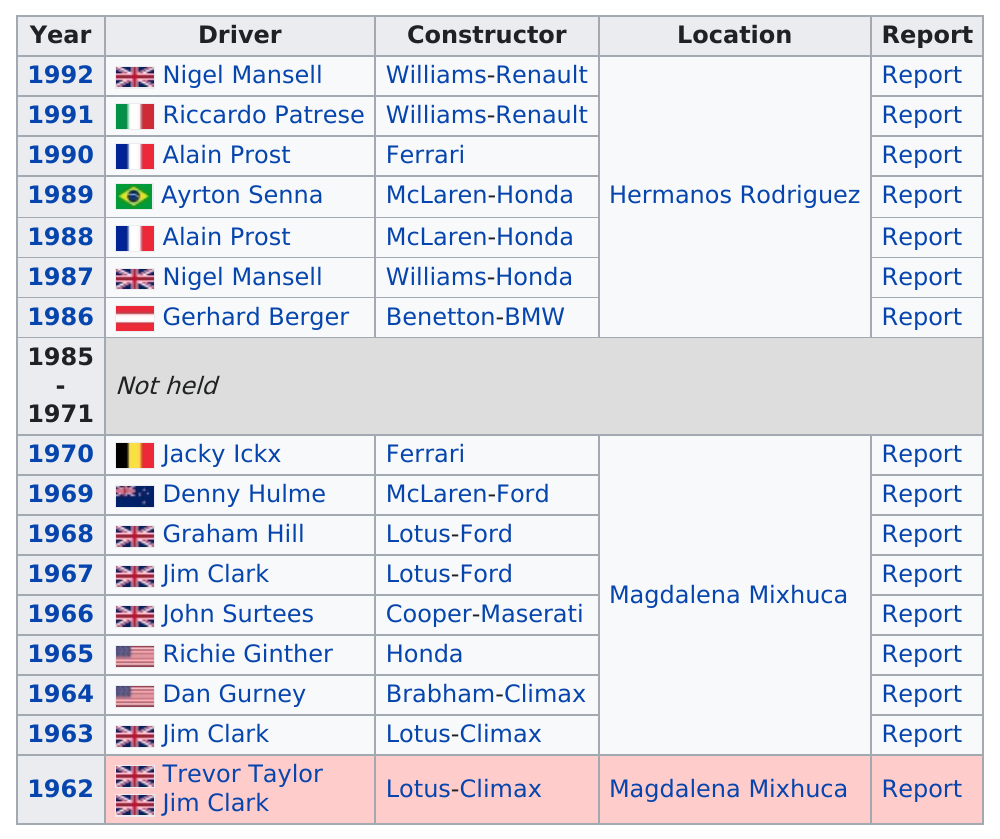Specify some key components in this picture. In 1962, Trevor Taylor and Jim Clark were the first drivers to win the Mexican Grand Prix. In 1988, Alan Prost drove for the constructor McLaren-Honda, not Ferrari. The driver who appears the most is Jim Clark. Dan Gurney was the first United States driver. Graham Hill did not win the previous race. Instead, it was Denny Hulme who won. 